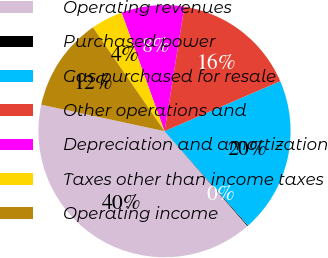<chart> <loc_0><loc_0><loc_500><loc_500><pie_chart><fcel>Operating revenues<fcel>Purchased power<fcel>Gas purchased for resale<fcel>Other operations and<fcel>Depreciation and amortization<fcel>Taxes other than income taxes<fcel>Operating income<nl><fcel>39.81%<fcel>0.1%<fcel>19.96%<fcel>15.99%<fcel>8.05%<fcel>4.08%<fcel>12.02%<nl></chart> 